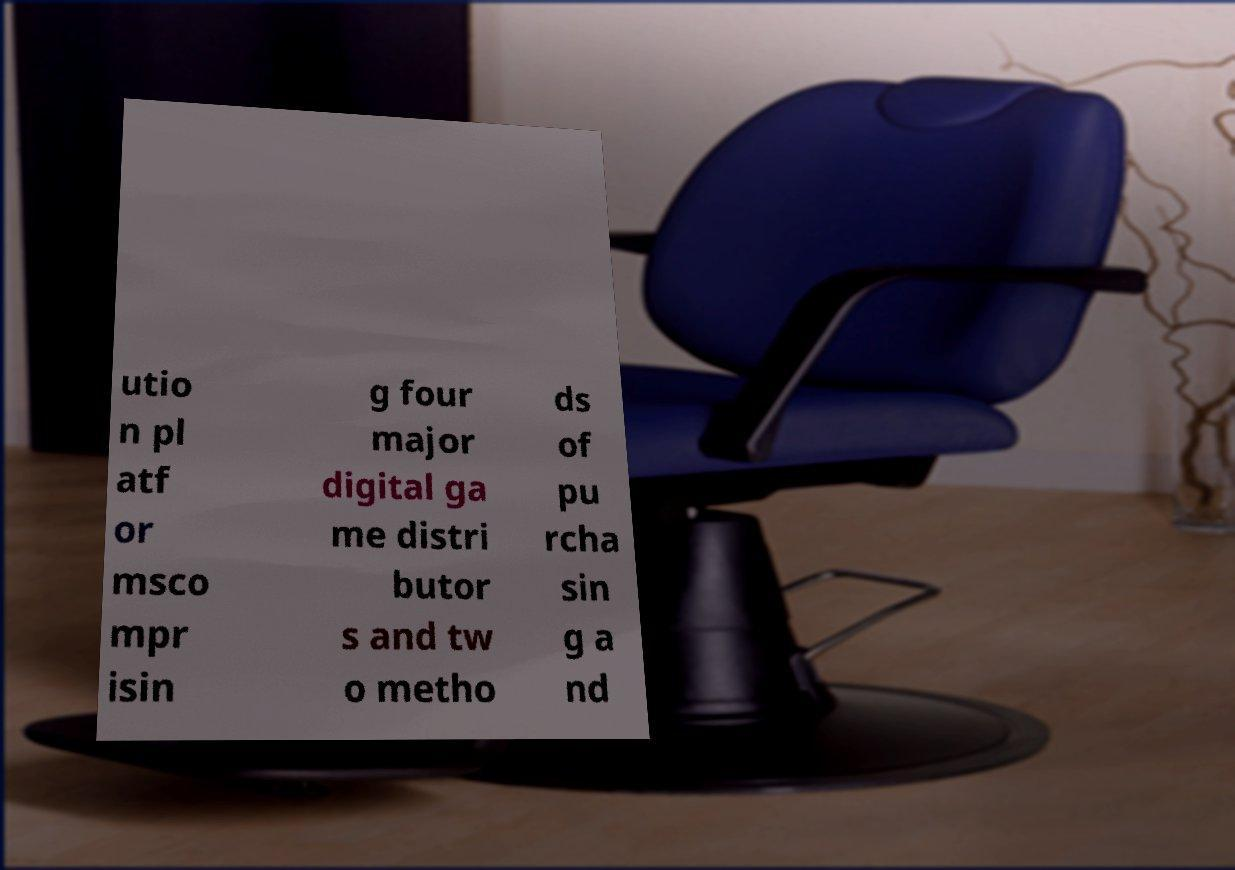Could you assist in decoding the text presented in this image and type it out clearly? utio n pl atf or msco mpr isin g four major digital ga me distri butor s and tw o metho ds of pu rcha sin g a nd 